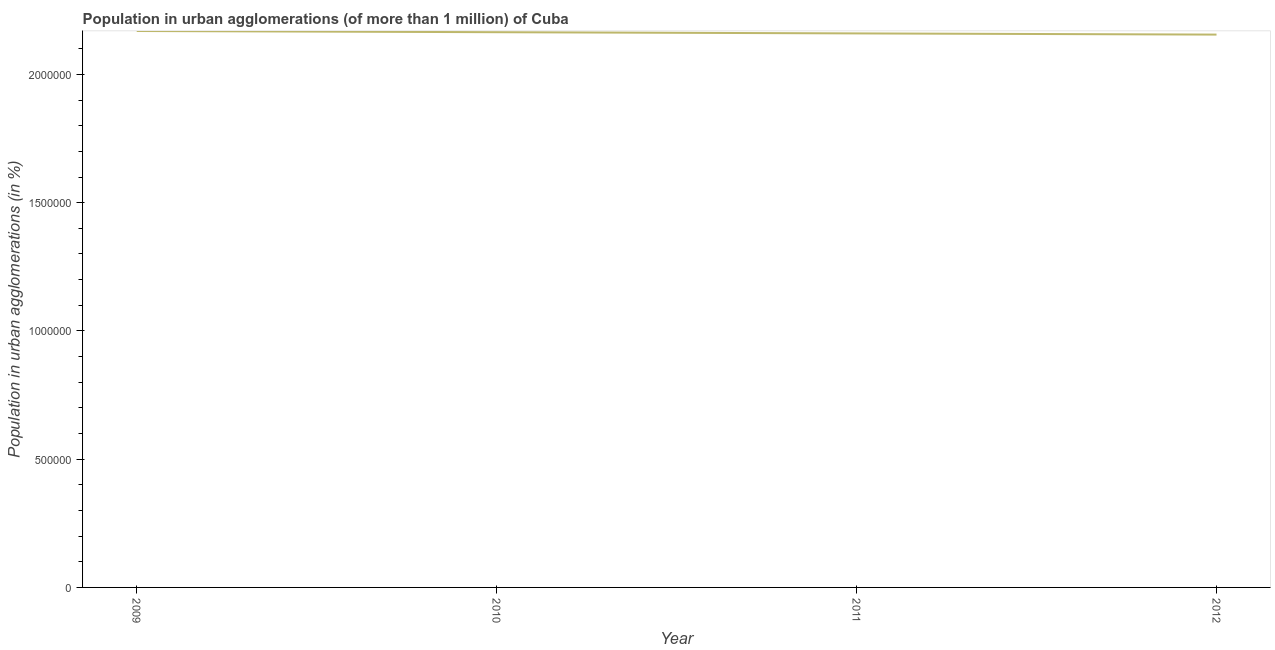What is the population in urban agglomerations in 2012?
Your answer should be compact. 2.16e+06. Across all years, what is the maximum population in urban agglomerations?
Offer a very short reply. 2.17e+06. Across all years, what is the minimum population in urban agglomerations?
Your response must be concise. 2.16e+06. In which year was the population in urban agglomerations maximum?
Your answer should be very brief. 2009. What is the sum of the population in urban agglomerations?
Offer a very short reply. 8.65e+06. What is the difference between the population in urban agglomerations in 2009 and 2010?
Ensure brevity in your answer.  4681. What is the average population in urban agglomerations per year?
Ensure brevity in your answer.  2.16e+06. What is the median population in urban agglomerations?
Provide a succinct answer. 2.16e+06. In how many years, is the population in urban agglomerations greater than 1100000 %?
Keep it short and to the point. 4. Do a majority of the years between 2010 and 2011 (inclusive) have population in urban agglomerations greater than 1900000 %?
Give a very brief answer. Yes. What is the ratio of the population in urban agglomerations in 2011 to that in 2012?
Your answer should be compact. 1. Is the population in urban agglomerations in 2010 less than that in 2012?
Give a very brief answer. No. Is the difference between the population in urban agglomerations in 2009 and 2011 greater than the difference between any two years?
Ensure brevity in your answer.  No. What is the difference between the highest and the second highest population in urban agglomerations?
Provide a succinct answer. 4681. What is the difference between the highest and the lowest population in urban agglomerations?
Your answer should be compact. 1.40e+04. In how many years, is the population in urban agglomerations greater than the average population in urban agglomerations taken over all years?
Provide a succinct answer. 2. Does the population in urban agglomerations monotonically increase over the years?
Offer a terse response. No. How many lines are there?
Provide a short and direct response. 1. Are the values on the major ticks of Y-axis written in scientific E-notation?
Offer a terse response. No. Does the graph contain grids?
Keep it short and to the point. No. What is the title of the graph?
Give a very brief answer. Population in urban agglomerations (of more than 1 million) of Cuba. What is the label or title of the Y-axis?
Keep it short and to the point. Population in urban agglomerations (in %). What is the Population in urban agglomerations (in %) in 2009?
Provide a succinct answer. 2.17e+06. What is the Population in urban agglomerations (in %) of 2010?
Offer a terse response. 2.16e+06. What is the Population in urban agglomerations (in %) in 2011?
Your response must be concise. 2.16e+06. What is the Population in urban agglomerations (in %) of 2012?
Keep it short and to the point. 2.16e+06. What is the difference between the Population in urban agglomerations (in %) in 2009 and 2010?
Make the answer very short. 4681. What is the difference between the Population in urban agglomerations (in %) in 2009 and 2011?
Make the answer very short. 9352. What is the difference between the Population in urban agglomerations (in %) in 2009 and 2012?
Offer a very short reply. 1.40e+04. What is the difference between the Population in urban agglomerations (in %) in 2010 and 2011?
Offer a terse response. 4671. What is the difference between the Population in urban agglomerations (in %) in 2010 and 2012?
Offer a terse response. 9339. What is the difference between the Population in urban agglomerations (in %) in 2011 and 2012?
Offer a very short reply. 4668. What is the ratio of the Population in urban agglomerations (in %) in 2009 to that in 2010?
Provide a succinct answer. 1. What is the ratio of the Population in urban agglomerations (in %) in 2010 to that in 2012?
Your response must be concise. 1. 